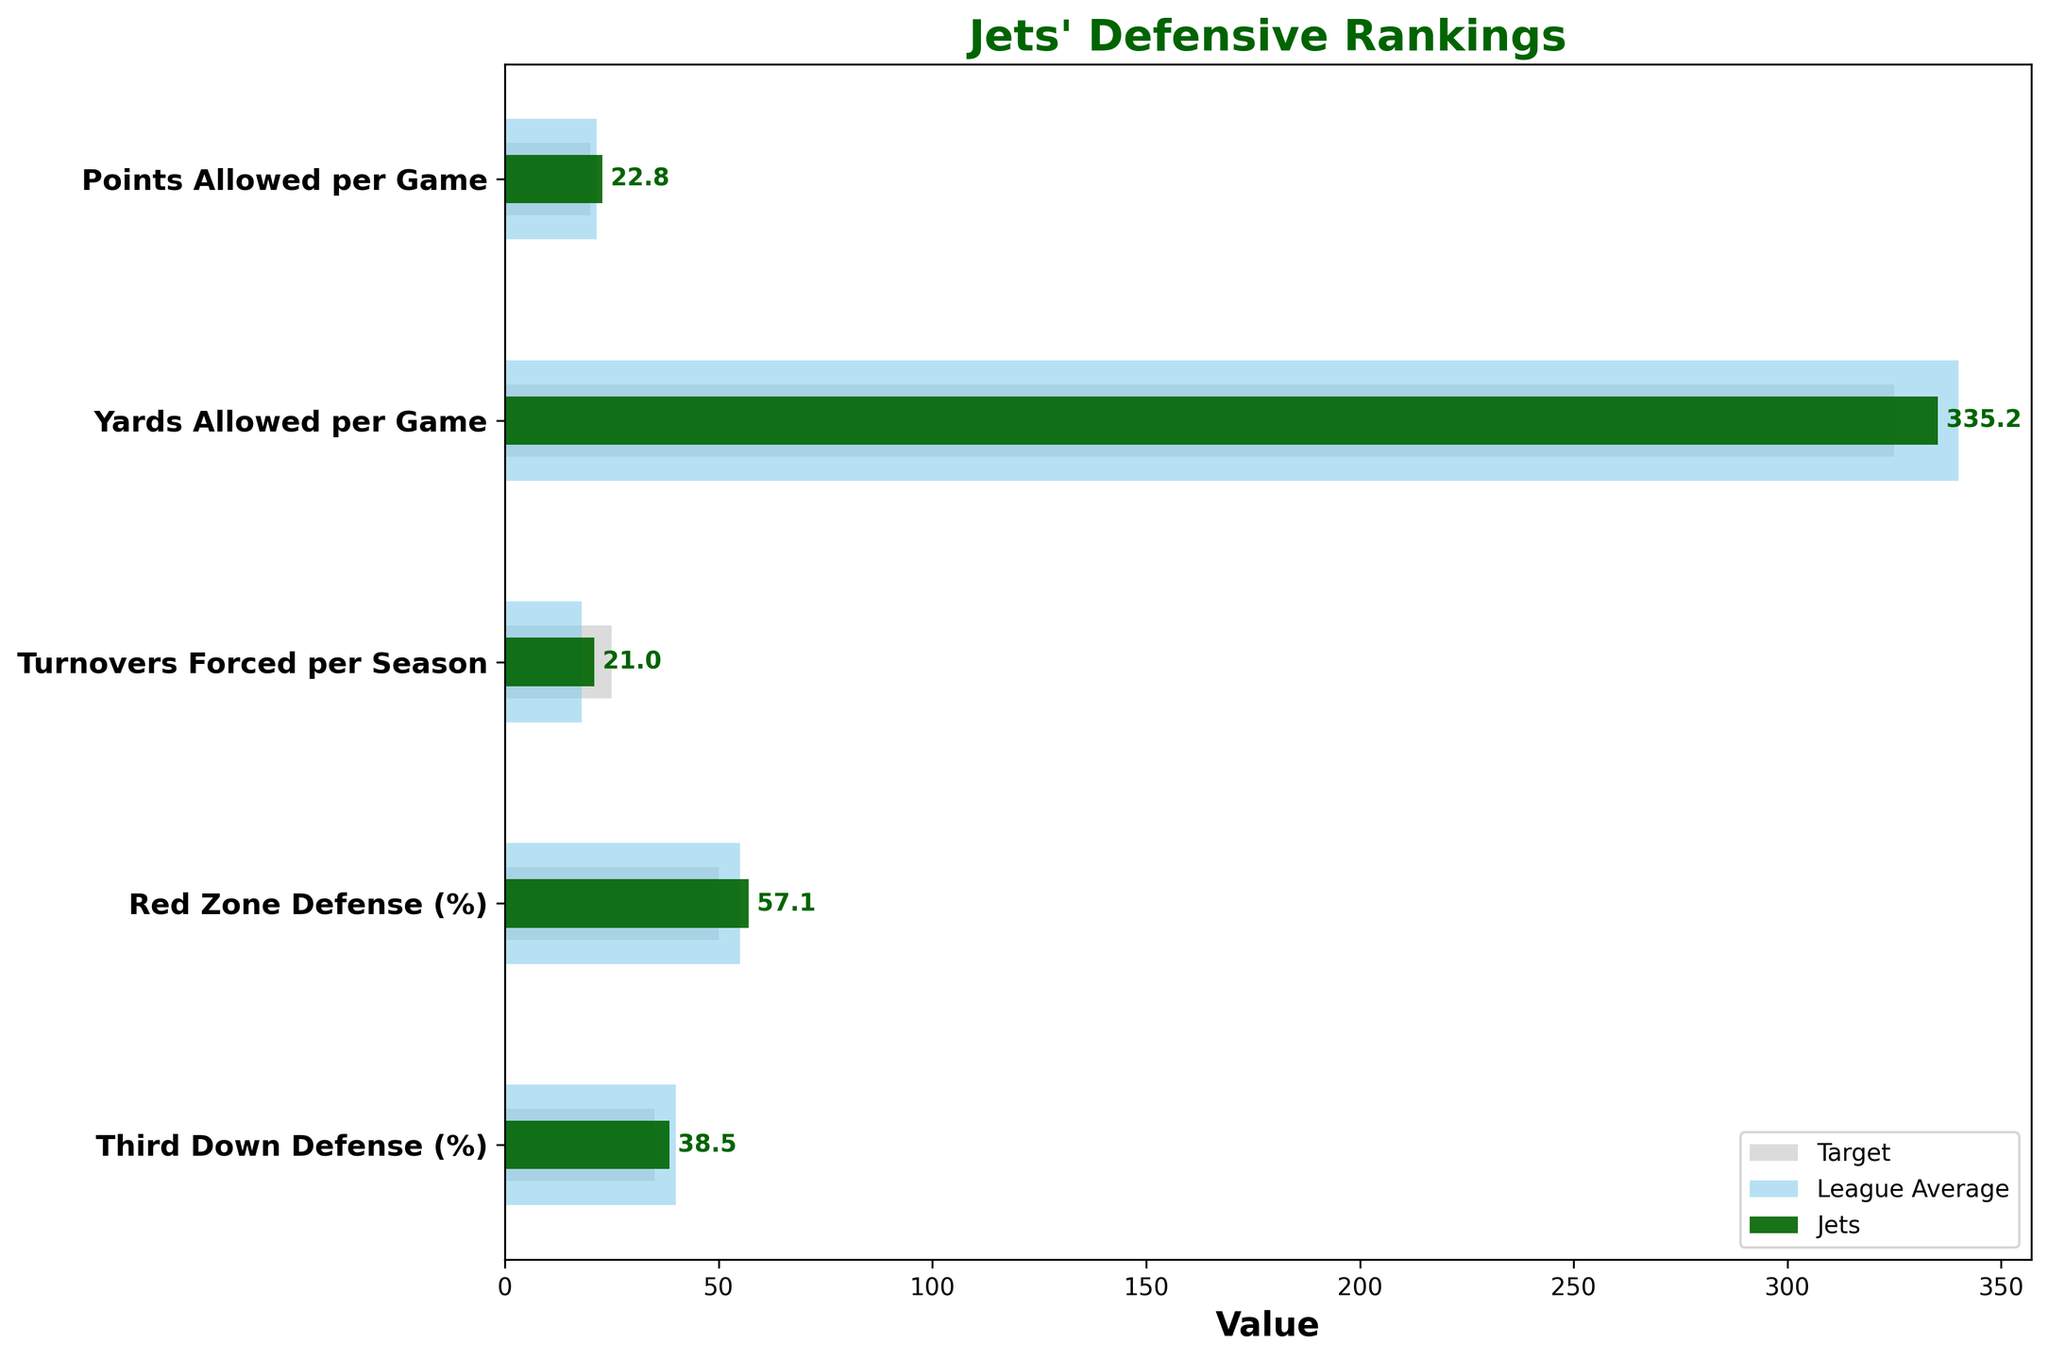What's the category with the highest actual value for the Jets? From the plot, scan the bars colored in dark green (representing the Jets' actual values) and find the category with the longest bar. In this case, it's "Yards Allowed per Game."
Answer: Yards Allowed per Game How does the Jets' red zone defense percentage compare to the league average? Refer to the "Red Zone Defense (%)" bars. The dark green bar represents the Jets (57.1%), and the sky blue bar represents the league average (55%). Compare these two values.
Answer: Jets' percentage is higher What's the difference between the Jets' actual points allowed per game and their target? Look at the "Points Allowed per Game" category. Subtract the target value (20) from the Jets' actual value (22.8).
Answer: 2.8 Which category shows the smallest gap between the Jets' actual value and their target? Compare the differences between the Jets' actual values (dark green bars) and their corresponding targets (light grey bars) for each category. The smallest difference appears in "Yards Allowed per Game" (335.2 - 325 = 10.2).
Answer: Yards Allowed per Game In which category do the Jets outperform the league average by the largest margin? Identify each category's comparison by looking at the difference between the Jets' actual values (dark green) and the comparative league average values (sky blue). The largest positive difference appears in the "Turnovers Forced per Season" category (21 vs. 18).
Answer: Turnovers Forced per Season What's the difference between the Jets' third down defense percentage and their target? Look at the "Third Down Defense (%)" category. Subtract the target value (35) from the Jets' actual value (38.5).
Answer: 3.5 How many categories have the Jets achieved better than the league average? Compare each category by examining if the dark green bar (Jets' actual value) is better (lower for percentages, higher for counts) than the sky blue bar (league average). The Jets perform better in two categories: "Turnovers Forced per Season" and "Third Down Defense (%)".
Answer: 2 What's the target value for points allowed per game? Look at the "Points Allowed per Game" category and refer to the length of the light grey bar, which represents the target value.
Answer: 20 Which category shows the Jets having the worst performance relative to their target? Evaluate each category by finding the category with the largest positive difference between the Jets' actual value and the target value. "Red Zone Defense (%)" shows the largest difference (57.1% - 50% = 7.1%).
Answer: Red Zone Defense (%) How close is the Jets' actual value for yards allowed per game to the league average? For the "Yards Allowed per Game" category, check the dark green bar (Jets' actual value at 335.2) and the sky blue bar (league average at 340). Subtract to find the difference (340 - 335.2 = 4.8).
Answer: 4.8 